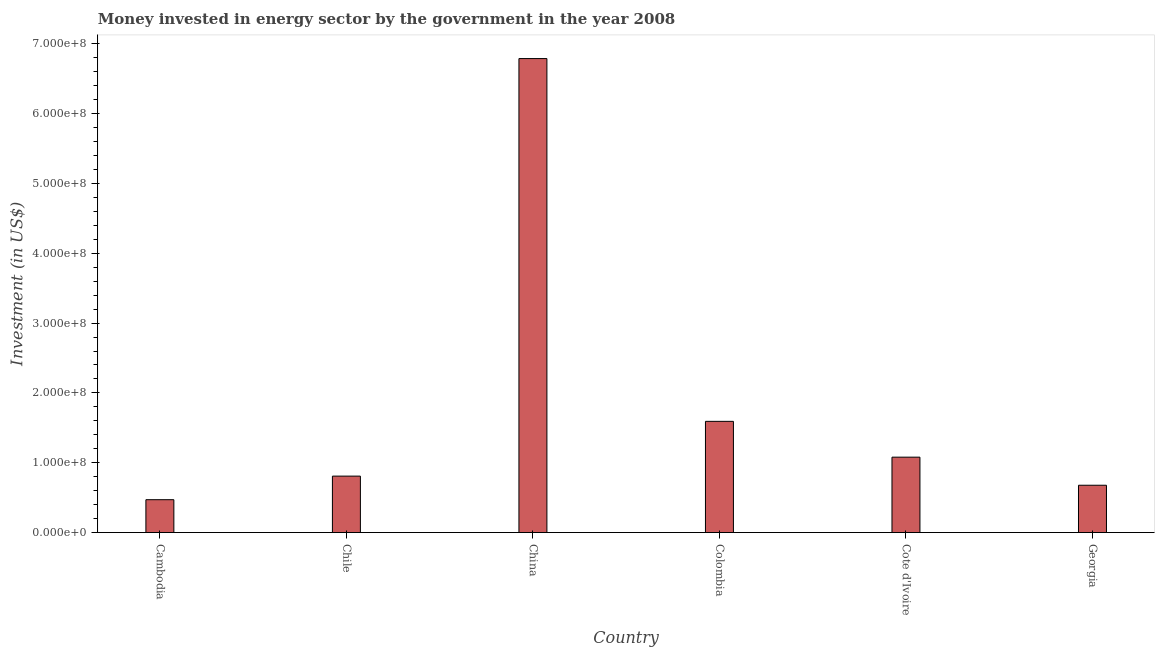What is the title of the graph?
Provide a succinct answer. Money invested in energy sector by the government in the year 2008. What is the label or title of the Y-axis?
Provide a short and direct response. Investment (in US$). What is the investment in energy in Chile?
Provide a succinct answer. 8.09e+07. Across all countries, what is the maximum investment in energy?
Ensure brevity in your answer.  6.79e+08. Across all countries, what is the minimum investment in energy?
Provide a short and direct response. 4.71e+07. In which country was the investment in energy maximum?
Provide a succinct answer. China. In which country was the investment in energy minimum?
Give a very brief answer. Cambodia. What is the sum of the investment in energy?
Your response must be concise. 1.14e+09. What is the difference between the investment in energy in Cambodia and Colombia?
Keep it short and to the point. -1.12e+08. What is the average investment in energy per country?
Your answer should be very brief. 1.90e+08. What is the median investment in energy?
Offer a very short reply. 9.44e+07. In how many countries, is the investment in energy greater than 300000000 US$?
Your response must be concise. 1. What is the ratio of the investment in energy in China to that in Cote d'Ivoire?
Offer a terse response. 6.29. Is the investment in energy in Chile less than that in Colombia?
Your answer should be very brief. Yes. What is the difference between the highest and the second highest investment in energy?
Your response must be concise. 5.19e+08. What is the difference between the highest and the lowest investment in energy?
Your response must be concise. 6.32e+08. How many bars are there?
Make the answer very short. 6. How many countries are there in the graph?
Your answer should be very brief. 6. What is the difference between two consecutive major ticks on the Y-axis?
Keep it short and to the point. 1.00e+08. What is the Investment (in US$) of Cambodia?
Keep it short and to the point. 4.71e+07. What is the Investment (in US$) of Chile?
Provide a succinct answer. 8.09e+07. What is the Investment (in US$) in China?
Ensure brevity in your answer.  6.79e+08. What is the Investment (in US$) of Colombia?
Give a very brief answer. 1.59e+08. What is the Investment (in US$) of Cote d'Ivoire?
Your response must be concise. 1.08e+08. What is the Investment (in US$) in Georgia?
Make the answer very short. 6.78e+07. What is the difference between the Investment (in US$) in Cambodia and Chile?
Offer a terse response. -3.38e+07. What is the difference between the Investment (in US$) in Cambodia and China?
Offer a terse response. -6.32e+08. What is the difference between the Investment (in US$) in Cambodia and Colombia?
Make the answer very short. -1.12e+08. What is the difference between the Investment (in US$) in Cambodia and Cote d'Ivoire?
Your response must be concise. -6.09e+07. What is the difference between the Investment (in US$) in Cambodia and Georgia?
Give a very brief answer. -2.07e+07. What is the difference between the Investment (in US$) in Chile and China?
Offer a terse response. -5.98e+08. What is the difference between the Investment (in US$) in Chile and Colombia?
Offer a terse response. -7.84e+07. What is the difference between the Investment (in US$) in Chile and Cote d'Ivoire?
Ensure brevity in your answer.  -2.71e+07. What is the difference between the Investment (in US$) in Chile and Georgia?
Keep it short and to the point. 1.31e+07. What is the difference between the Investment (in US$) in China and Colombia?
Your answer should be very brief. 5.19e+08. What is the difference between the Investment (in US$) in China and Cote d'Ivoire?
Offer a very short reply. 5.71e+08. What is the difference between the Investment (in US$) in China and Georgia?
Make the answer very short. 6.11e+08. What is the difference between the Investment (in US$) in Colombia and Cote d'Ivoire?
Offer a terse response. 5.13e+07. What is the difference between the Investment (in US$) in Colombia and Georgia?
Your answer should be compact. 9.15e+07. What is the difference between the Investment (in US$) in Cote d'Ivoire and Georgia?
Your response must be concise. 4.02e+07. What is the ratio of the Investment (in US$) in Cambodia to that in Chile?
Make the answer very short. 0.58. What is the ratio of the Investment (in US$) in Cambodia to that in China?
Keep it short and to the point. 0.07. What is the ratio of the Investment (in US$) in Cambodia to that in Colombia?
Offer a terse response. 0.3. What is the ratio of the Investment (in US$) in Cambodia to that in Cote d'Ivoire?
Your response must be concise. 0.44. What is the ratio of the Investment (in US$) in Cambodia to that in Georgia?
Your answer should be compact. 0.69. What is the ratio of the Investment (in US$) in Chile to that in China?
Keep it short and to the point. 0.12. What is the ratio of the Investment (in US$) in Chile to that in Colombia?
Provide a succinct answer. 0.51. What is the ratio of the Investment (in US$) in Chile to that in Cote d'Ivoire?
Provide a succinct answer. 0.75. What is the ratio of the Investment (in US$) in Chile to that in Georgia?
Your answer should be compact. 1.19. What is the ratio of the Investment (in US$) in China to that in Colombia?
Provide a succinct answer. 4.26. What is the ratio of the Investment (in US$) in China to that in Cote d'Ivoire?
Offer a terse response. 6.29. What is the ratio of the Investment (in US$) in China to that in Georgia?
Offer a very short reply. 10.01. What is the ratio of the Investment (in US$) in Colombia to that in Cote d'Ivoire?
Provide a succinct answer. 1.48. What is the ratio of the Investment (in US$) in Colombia to that in Georgia?
Give a very brief answer. 2.35. What is the ratio of the Investment (in US$) in Cote d'Ivoire to that in Georgia?
Your answer should be very brief. 1.59. 